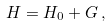Convert formula to latex. <formula><loc_0><loc_0><loc_500><loc_500>H = H _ { 0 } + G \, ,</formula> 